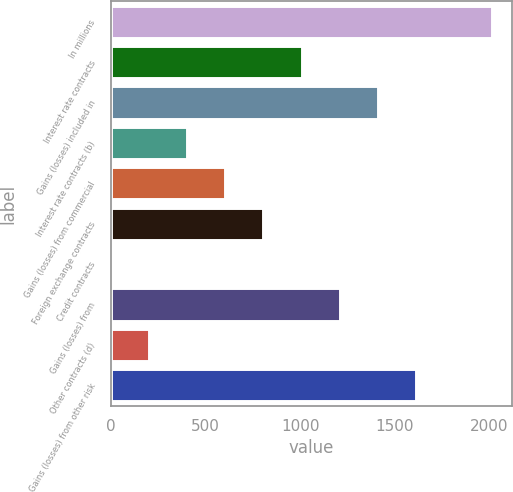Convert chart to OTSL. <chart><loc_0><loc_0><loc_500><loc_500><bar_chart><fcel>In millions<fcel>Interest rate contracts<fcel>Gains (losses) included in<fcel>Interest rate contracts (b)<fcel>Gains (losses) from commercial<fcel>Foreign exchange contracts<fcel>Credit contracts<fcel>Gains (losses) from<fcel>Other contracts (d)<fcel>Gains (losses) from other risk<nl><fcel>2015<fcel>1008<fcel>1410.8<fcel>403.8<fcel>605.2<fcel>806.6<fcel>1<fcel>1209.4<fcel>202.4<fcel>1612.2<nl></chart> 